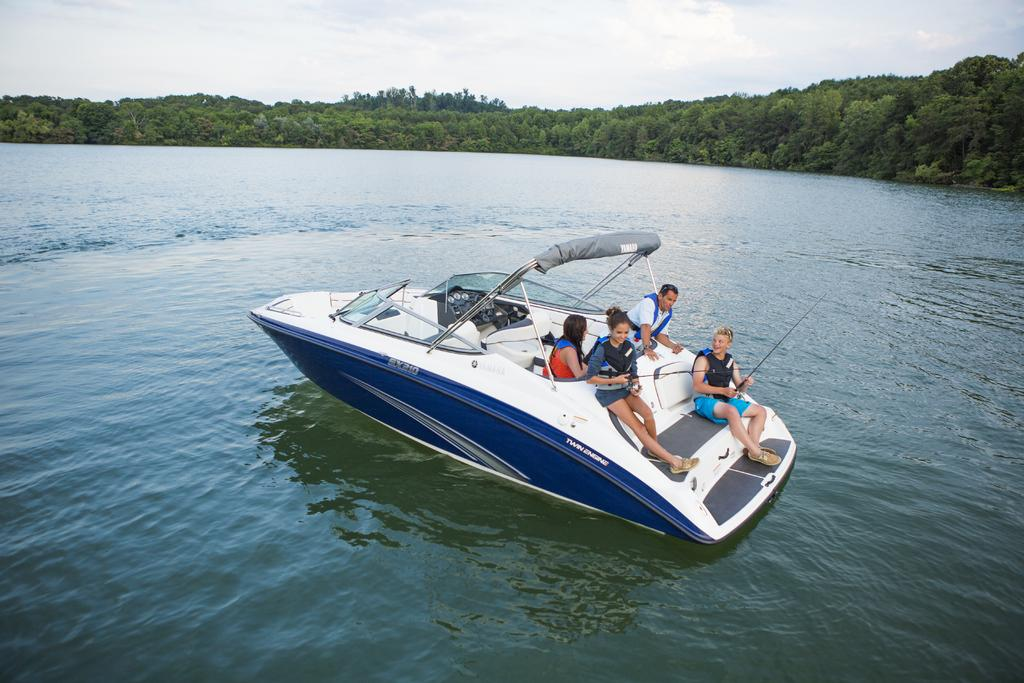What is the main subject in the foreground of the image? There is a boat in the foreground of the image. How many people are on the boat? There are four persons on the boat. What can be seen in the background of the image? There is water, trees, and clouds visible in the background of the image. What type of trousers is the writer wearing in the image? There is no writer present in the image, and therefore no trousers to describe. 